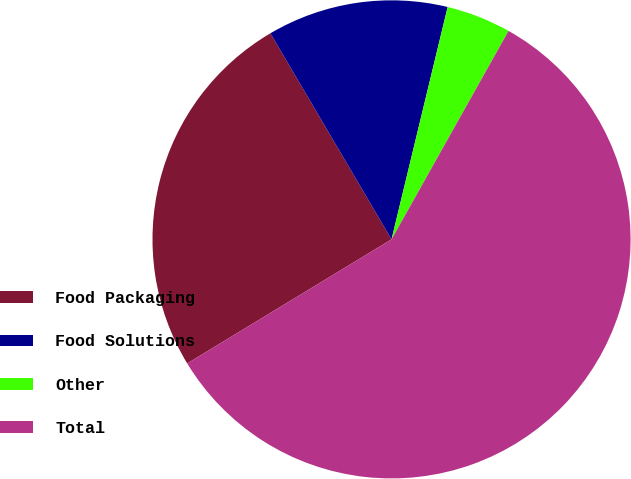<chart> <loc_0><loc_0><loc_500><loc_500><pie_chart><fcel>Food Packaging<fcel>Food Solutions<fcel>Other<fcel>Total<nl><fcel>25.23%<fcel>12.23%<fcel>4.37%<fcel>58.18%<nl></chart> 